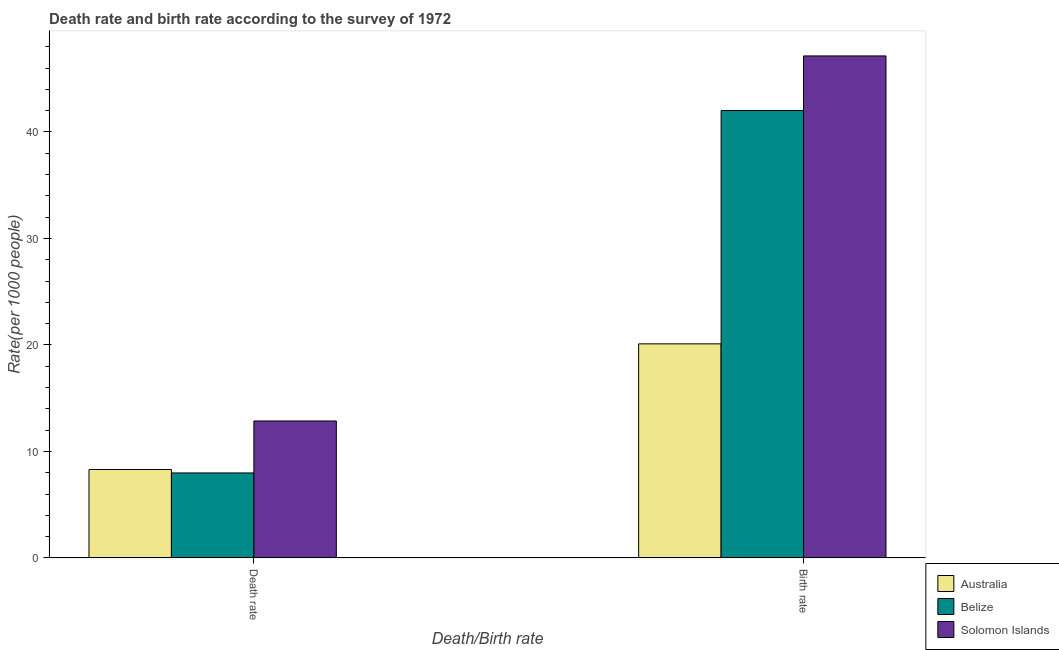How many different coloured bars are there?
Your response must be concise. 3. How many groups of bars are there?
Keep it short and to the point. 2. What is the label of the 2nd group of bars from the left?
Offer a terse response. Birth rate. What is the birth rate in Solomon Islands?
Ensure brevity in your answer.  47.14. Across all countries, what is the maximum death rate?
Provide a short and direct response. 12.86. Across all countries, what is the minimum birth rate?
Your response must be concise. 20.1. In which country was the birth rate maximum?
Your answer should be compact. Solomon Islands. What is the total death rate in the graph?
Keep it short and to the point. 29.13. What is the difference between the birth rate in Solomon Islands and that in Australia?
Offer a very short reply. 27.04. What is the difference between the death rate in Solomon Islands and the birth rate in Australia?
Your answer should be very brief. -7.24. What is the average death rate per country?
Offer a very short reply. 9.71. What is the difference between the birth rate and death rate in Solomon Islands?
Provide a short and direct response. 34.28. In how many countries, is the birth rate greater than 18 ?
Provide a short and direct response. 3. What is the ratio of the death rate in Australia to that in Belize?
Offer a terse response. 1.04. In how many countries, is the death rate greater than the average death rate taken over all countries?
Your response must be concise. 1. What does the 2nd bar from the left in Birth rate represents?
Ensure brevity in your answer.  Belize. What does the 1st bar from the right in Birth rate represents?
Offer a terse response. Solomon Islands. How many countries are there in the graph?
Provide a short and direct response. 3. What is the difference between two consecutive major ticks on the Y-axis?
Your response must be concise. 10. Does the graph contain any zero values?
Offer a very short reply. No. Does the graph contain grids?
Keep it short and to the point. No. How are the legend labels stacked?
Keep it short and to the point. Vertical. What is the title of the graph?
Offer a very short reply. Death rate and birth rate according to the survey of 1972. Does "Armenia" appear as one of the legend labels in the graph?
Your response must be concise. No. What is the label or title of the X-axis?
Your response must be concise. Death/Birth rate. What is the label or title of the Y-axis?
Provide a succinct answer. Rate(per 1000 people). What is the Rate(per 1000 people) in Belize in Death rate?
Make the answer very short. 7.98. What is the Rate(per 1000 people) of Solomon Islands in Death rate?
Provide a short and direct response. 12.86. What is the Rate(per 1000 people) of Australia in Birth rate?
Your answer should be compact. 20.1. What is the Rate(per 1000 people) of Belize in Birth rate?
Your answer should be compact. 42.01. What is the Rate(per 1000 people) of Solomon Islands in Birth rate?
Keep it short and to the point. 47.14. Across all Death/Birth rate, what is the maximum Rate(per 1000 people) in Australia?
Keep it short and to the point. 20.1. Across all Death/Birth rate, what is the maximum Rate(per 1000 people) of Belize?
Your answer should be compact. 42.01. Across all Death/Birth rate, what is the maximum Rate(per 1000 people) in Solomon Islands?
Keep it short and to the point. 47.14. Across all Death/Birth rate, what is the minimum Rate(per 1000 people) of Belize?
Provide a succinct answer. 7.98. Across all Death/Birth rate, what is the minimum Rate(per 1000 people) of Solomon Islands?
Give a very brief answer. 12.86. What is the total Rate(per 1000 people) of Australia in the graph?
Your response must be concise. 28.4. What is the total Rate(per 1000 people) of Belize in the graph?
Your response must be concise. 49.98. What is the total Rate(per 1000 people) of Solomon Islands in the graph?
Your answer should be compact. 59.99. What is the difference between the Rate(per 1000 people) of Belize in Death rate and that in Birth rate?
Give a very brief answer. -34.03. What is the difference between the Rate(per 1000 people) in Solomon Islands in Death rate and that in Birth rate?
Give a very brief answer. -34.28. What is the difference between the Rate(per 1000 people) in Australia in Death rate and the Rate(per 1000 people) in Belize in Birth rate?
Offer a very short reply. -33.71. What is the difference between the Rate(per 1000 people) in Australia in Death rate and the Rate(per 1000 people) in Solomon Islands in Birth rate?
Your answer should be compact. -38.84. What is the difference between the Rate(per 1000 people) in Belize in Death rate and the Rate(per 1000 people) in Solomon Islands in Birth rate?
Make the answer very short. -39.16. What is the average Rate(per 1000 people) of Australia per Death/Birth rate?
Provide a short and direct response. 14.2. What is the average Rate(per 1000 people) in Belize per Death/Birth rate?
Provide a succinct answer. 24.99. What is the average Rate(per 1000 people) of Solomon Islands per Death/Birth rate?
Offer a very short reply. 30. What is the difference between the Rate(per 1000 people) in Australia and Rate(per 1000 people) in Belize in Death rate?
Your answer should be very brief. 0.32. What is the difference between the Rate(per 1000 people) in Australia and Rate(per 1000 people) in Solomon Islands in Death rate?
Keep it short and to the point. -4.56. What is the difference between the Rate(per 1000 people) in Belize and Rate(per 1000 people) in Solomon Islands in Death rate?
Keep it short and to the point. -4.88. What is the difference between the Rate(per 1000 people) of Australia and Rate(per 1000 people) of Belize in Birth rate?
Offer a terse response. -21.91. What is the difference between the Rate(per 1000 people) in Australia and Rate(per 1000 people) in Solomon Islands in Birth rate?
Provide a succinct answer. -27.04. What is the difference between the Rate(per 1000 people) in Belize and Rate(per 1000 people) in Solomon Islands in Birth rate?
Make the answer very short. -5.13. What is the ratio of the Rate(per 1000 people) in Australia in Death rate to that in Birth rate?
Offer a terse response. 0.41. What is the ratio of the Rate(per 1000 people) of Belize in Death rate to that in Birth rate?
Give a very brief answer. 0.19. What is the ratio of the Rate(per 1000 people) of Solomon Islands in Death rate to that in Birth rate?
Ensure brevity in your answer.  0.27. What is the difference between the highest and the second highest Rate(per 1000 people) in Australia?
Your response must be concise. 11.8. What is the difference between the highest and the second highest Rate(per 1000 people) of Belize?
Your answer should be compact. 34.03. What is the difference between the highest and the second highest Rate(per 1000 people) of Solomon Islands?
Provide a succinct answer. 34.28. What is the difference between the highest and the lowest Rate(per 1000 people) of Belize?
Your answer should be very brief. 34.03. What is the difference between the highest and the lowest Rate(per 1000 people) of Solomon Islands?
Your answer should be very brief. 34.28. 